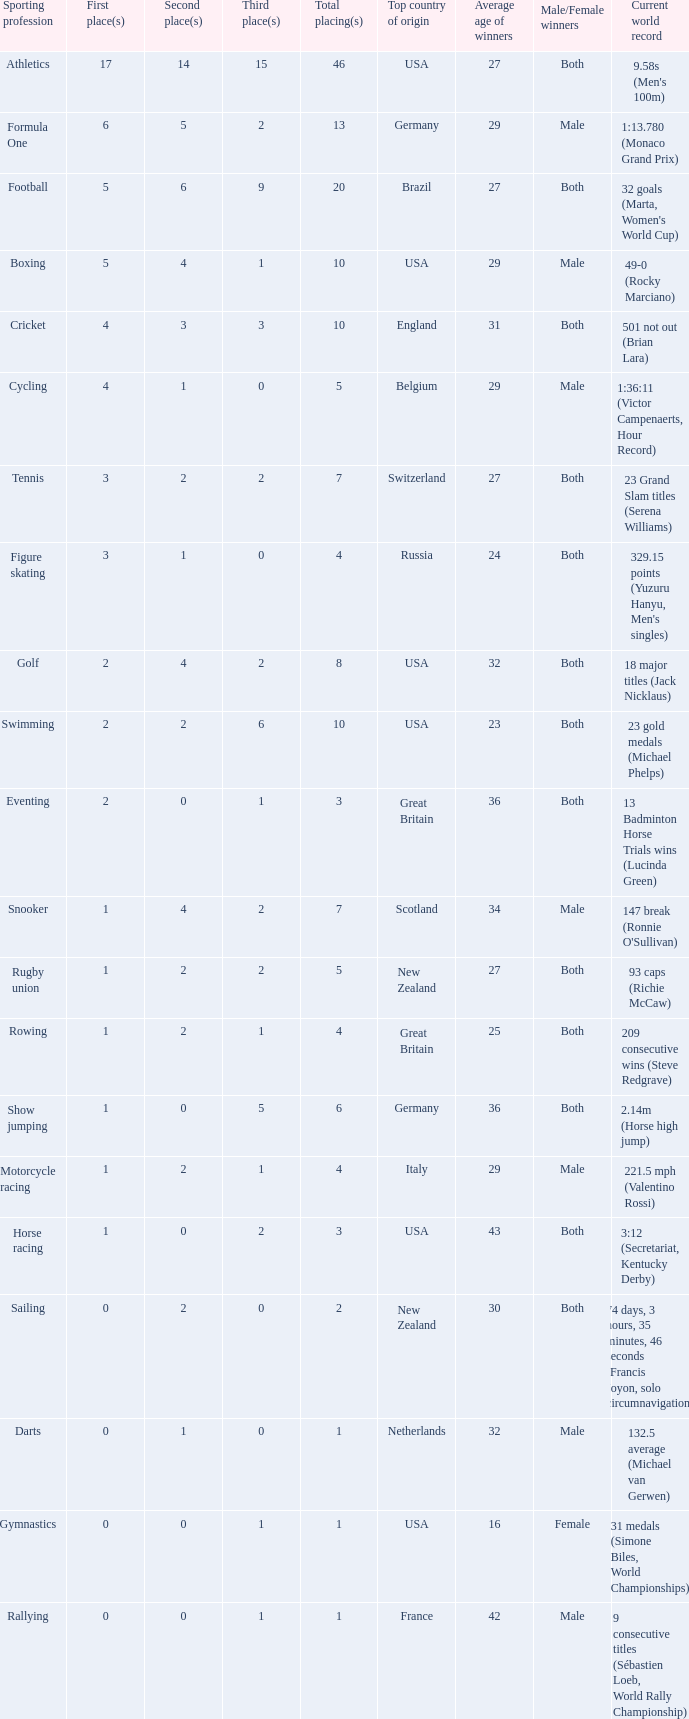How many second place showings does snooker have? 4.0. 